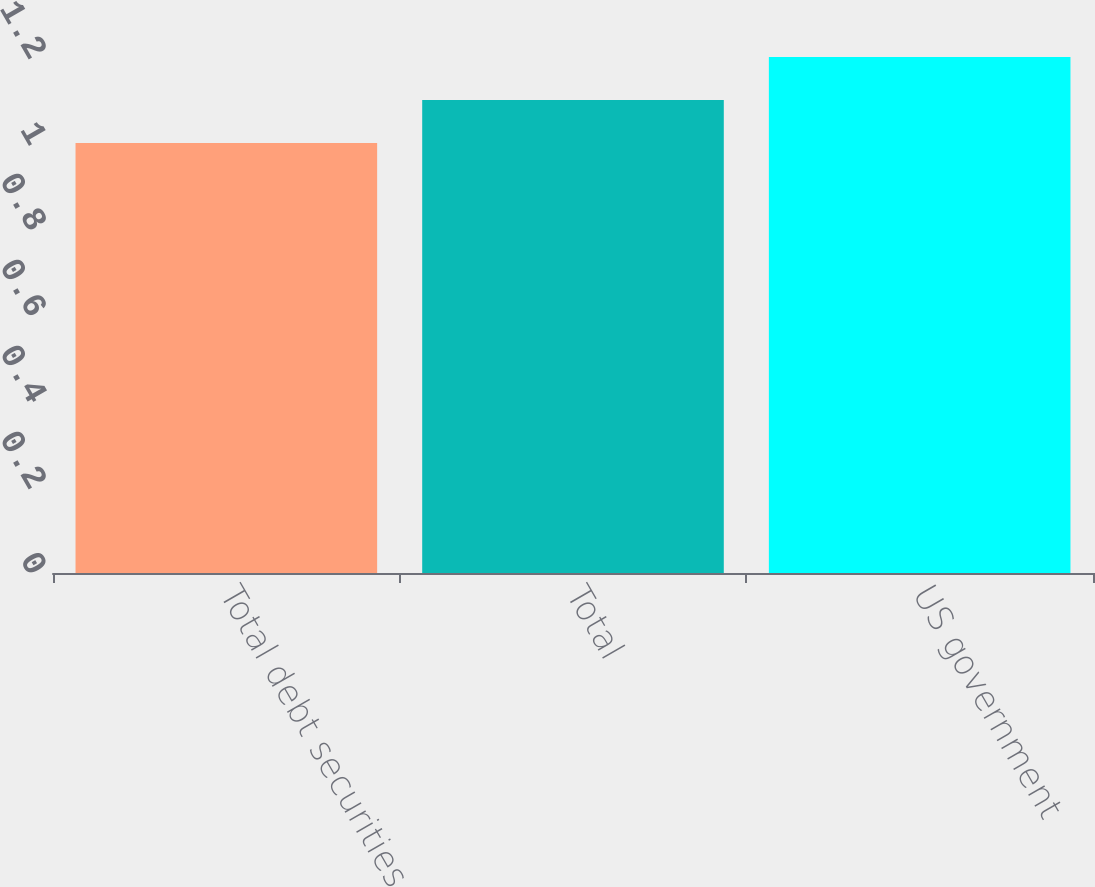Convert chart to OTSL. <chart><loc_0><loc_0><loc_500><loc_500><bar_chart><fcel>Total debt securities<fcel>Total<fcel>US government<nl><fcel>1<fcel>1.1<fcel>1.2<nl></chart> 